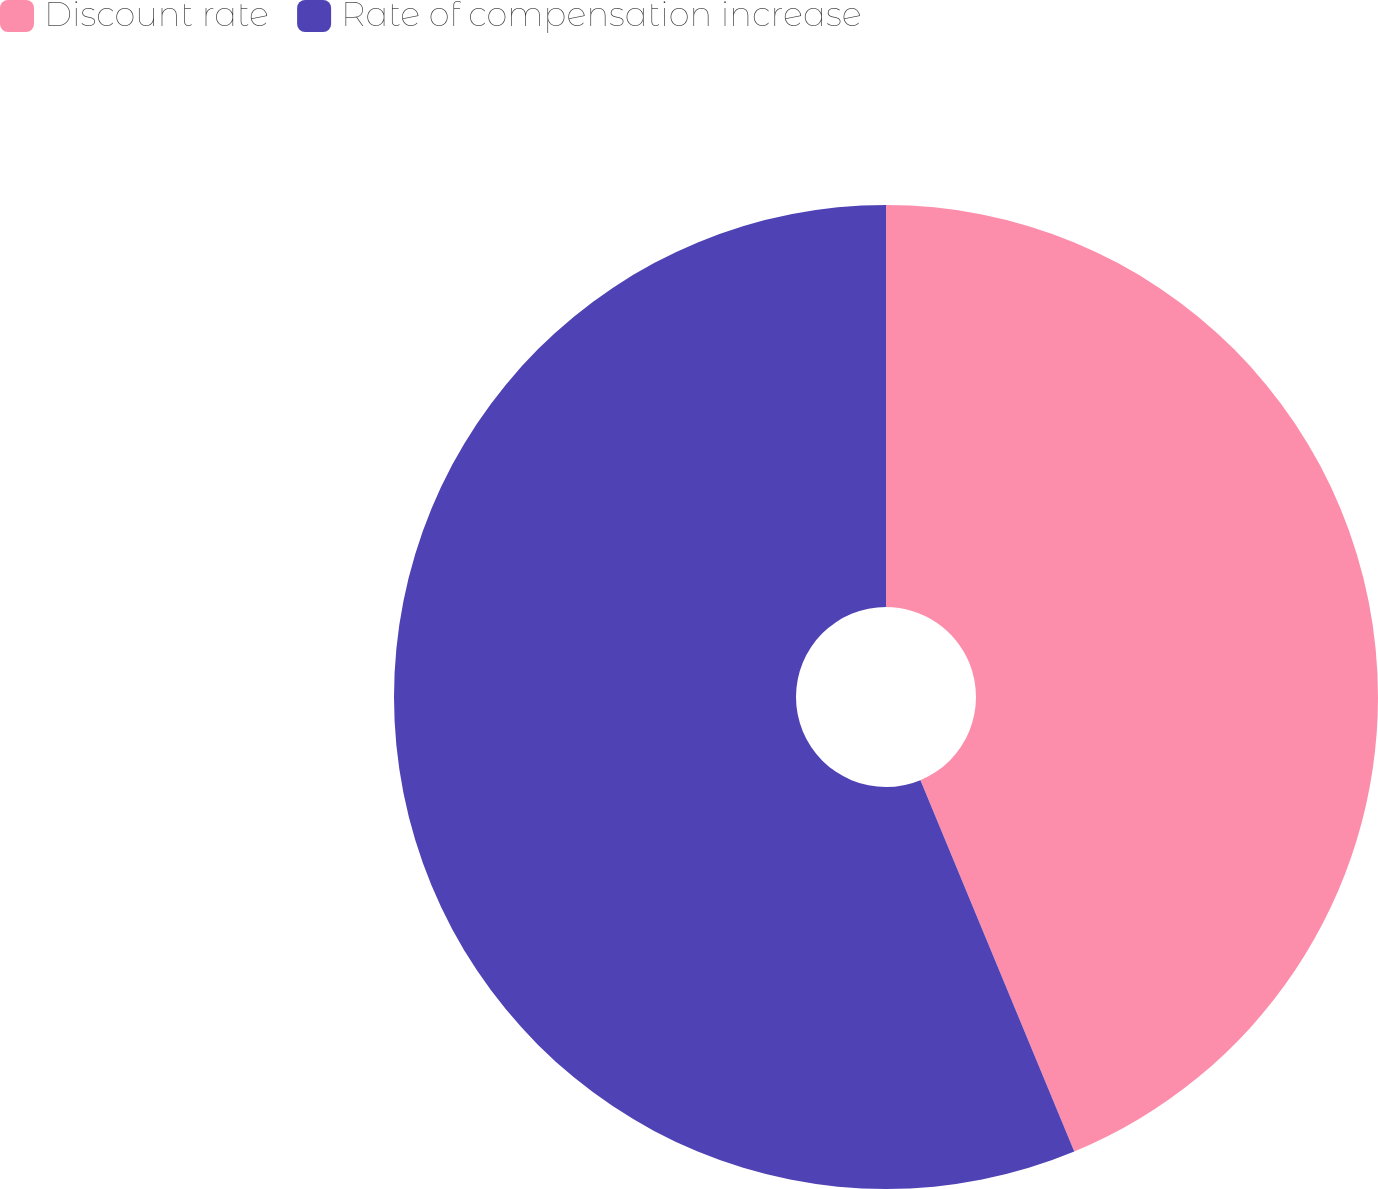Convert chart to OTSL. <chart><loc_0><loc_0><loc_500><loc_500><pie_chart><fcel>Discount rate<fcel>Rate of compensation increase<nl><fcel>43.75%<fcel>56.25%<nl></chart> 